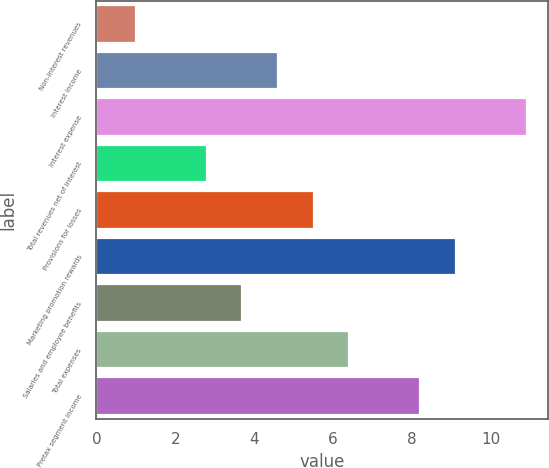Convert chart. <chart><loc_0><loc_0><loc_500><loc_500><bar_chart><fcel>Non-interest revenues<fcel>Interest income<fcel>Interest expense<fcel>Total revenues net of interest<fcel>Provisions for losses<fcel>Marketing promotion rewards<fcel>Salaries and employee benefits<fcel>Total expenses<fcel>Pretax segment income<nl><fcel>1<fcel>4.6<fcel>10.9<fcel>2.8<fcel>5.5<fcel>9.1<fcel>3.7<fcel>6.4<fcel>8.2<nl></chart> 